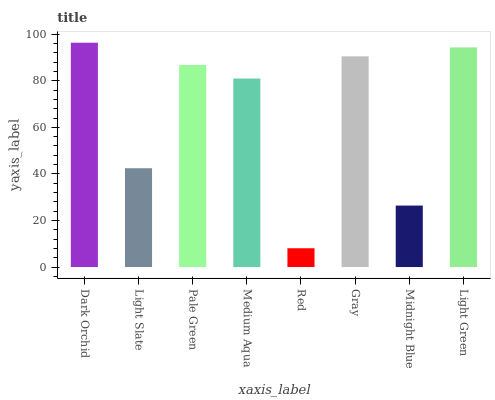Is Red the minimum?
Answer yes or no. Yes. Is Dark Orchid the maximum?
Answer yes or no. Yes. Is Light Slate the minimum?
Answer yes or no. No. Is Light Slate the maximum?
Answer yes or no. No. Is Dark Orchid greater than Light Slate?
Answer yes or no. Yes. Is Light Slate less than Dark Orchid?
Answer yes or no. Yes. Is Light Slate greater than Dark Orchid?
Answer yes or no. No. Is Dark Orchid less than Light Slate?
Answer yes or no. No. Is Pale Green the high median?
Answer yes or no. Yes. Is Medium Aqua the low median?
Answer yes or no. Yes. Is Medium Aqua the high median?
Answer yes or no. No. Is Dark Orchid the low median?
Answer yes or no. No. 